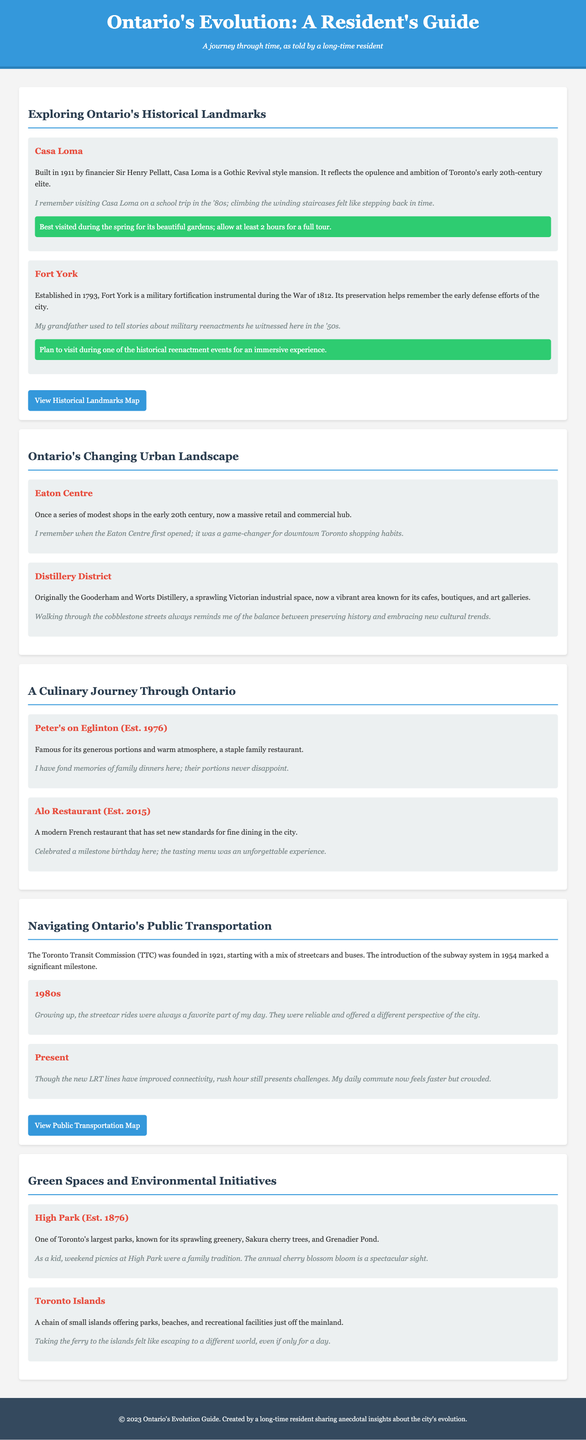What year was Casa Loma built? Casa Loma was constructed in 1911, as stated in the document.
Answer: 1911 What significant event did Fort York play a role in? Fort York is notably associated with the War of 1812, according to the text.
Answer: War of 1812 What was the original purpose of the Distillery District? The Distillery District was originally the Gooderham and Worts Distillery, which is mentioned in the section on Ontario's Changing Urban Landscape.
Answer: Gooderham and Worts Distillery What is the establishment year of High Park? High Park was established in 1876, as detailed in the guide.
Answer: 1876 In which decade was the Toronto Transit Commission founded? The document states the TTC was founded in 1921, which falls in the 1920s decade.
Answer: 1920s How does the document describe Ontario's culinary scene evolution? The guide highlights the transformation from long-standing family-owned establishments to modern culinary trends.
Answer: Transformation What was a personal experience with the streetcars mentioned in the document? The author fondly recalls that growing up, streetcar rides were always a favorite part of their day, indicating a positive childhood experience with public transport.
Answer: Favorite part of the day What recommendations are provided for visiting Casa Loma? The document advises visiting Casa Loma during spring for its gardens and allowing at least 2 hours for a full tour.
Answer: Visit in spring; allow at least 2 hours What type of cuisine does Alo Restaurant represent? Alo Restaurant is described as a modern French restaurant, showcasing a specific style of dining that has developed in Ontario.
Answer: Modern French 